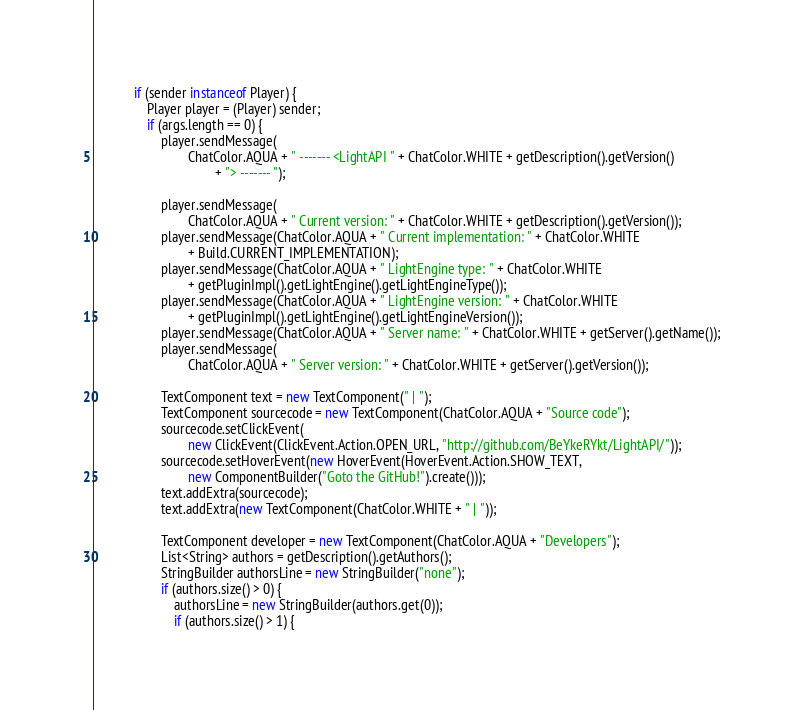<code> <loc_0><loc_0><loc_500><loc_500><_Java_>            if (sender instanceof Player) {
                Player player = (Player) sender;
                if (args.length == 0) {
                    player.sendMessage(
                            ChatColor.AQUA + " ------- <LightAPI " + ChatColor.WHITE + getDescription().getVersion()
                                    + "> ------- ");

                    player.sendMessage(
                            ChatColor.AQUA + " Current version: " + ChatColor.WHITE + getDescription().getVersion());
                    player.sendMessage(ChatColor.AQUA + " Current implementation: " + ChatColor.WHITE
                            + Build.CURRENT_IMPLEMENTATION);
                    player.sendMessage(ChatColor.AQUA + " LightEngine type: " + ChatColor.WHITE
                            + getPluginImpl().getLightEngine().getLightEngineType());
                    player.sendMessage(ChatColor.AQUA + " LightEngine version: " + ChatColor.WHITE
                            + getPluginImpl().getLightEngine().getLightEngineVersion());
                    player.sendMessage(ChatColor.AQUA + " Server name: " + ChatColor.WHITE + getServer().getName());
                    player.sendMessage(
                            ChatColor.AQUA + " Server version: " + ChatColor.WHITE + getServer().getVersion());

                    TextComponent text = new TextComponent(" | ");
                    TextComponent sourcecode = new TextComponent(ChatColor.AQUA + "Source code");
                    sourcecode.setClickEvent(
                            new ClickEvent(ClickEvent.Action.OPEN_URL, "http://github.com/BeYkeRYkt/LightAPI/"));
                    sourcecode.setHoverEvent(new HoverEvent(HoverEvent.Action.SHOW_TEXT,
                            new ComponentBuilder("Goto the GitHub!").create()));
                    text.addExtra(sourcecode);
                    text.addExtra(new TextComponent(ChatColor.WHITE + " | "));

                    TextComponent developer = new TextComponent(ChatColor.AQUA + "Developers");
                    List<String> authors = getDescription().getAuthors();
                    StringBuilder authorsLine = new StringBuilder("none");
                    if (authors.size() > 0) {
                        authorsLine = new StringBuilder(authors.get(0));
                        if (authors.size() > 1) {</code> 